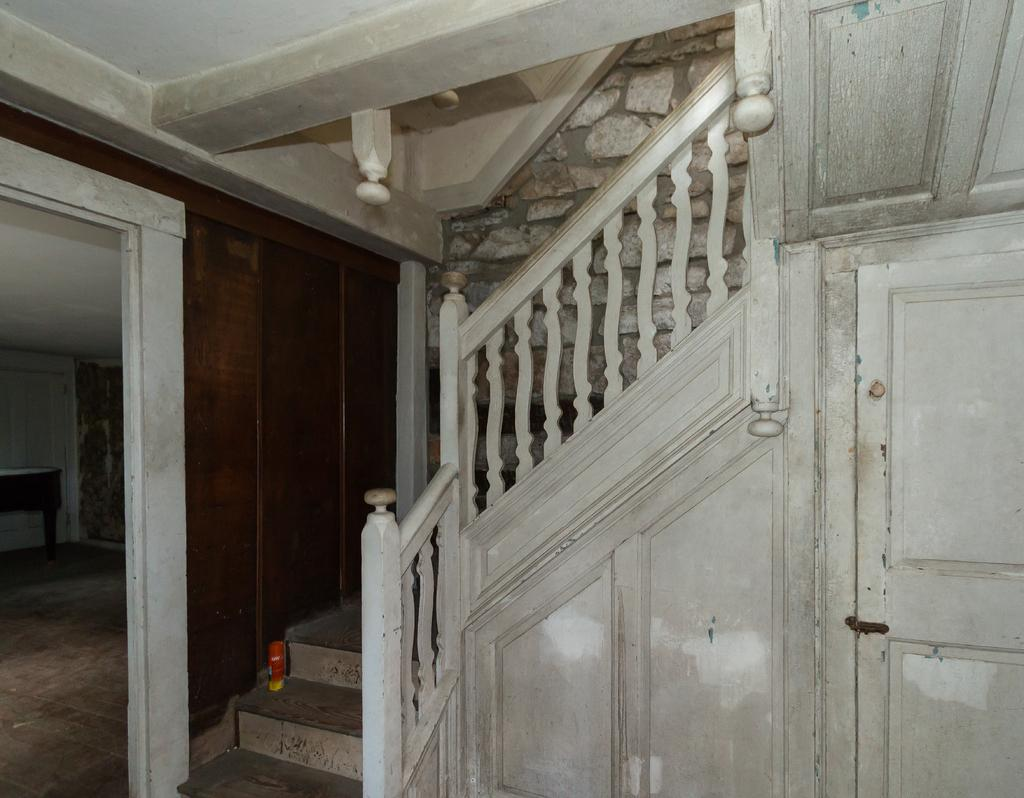What type of location is depicted in the image? The image shows an inside view of a house. What piece of furniture can be seen in the image? There is a table in the image. Are there any architectural features visible in the image? Yes, there are stairs in the image. What can be seen in the background of the image? There is a wall visible in the background of the image. How many eyes can be seen on the furniture in the image? There is no furniture with eyes present in the image. What force is being exerted on the wall in the image? There is no force being exerted on the wall in the image; it is stationary. 